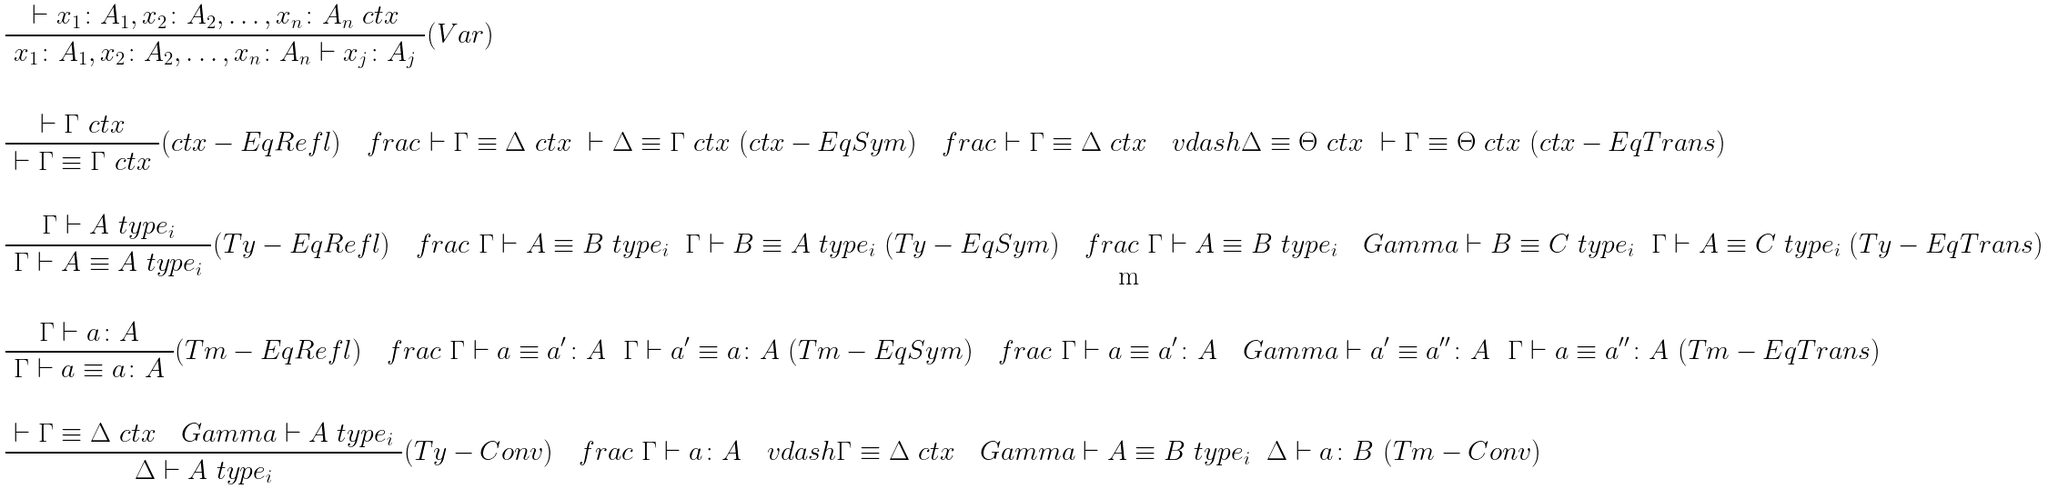Convert formula to latex. <formula><loc_0><loc_0><loc_500><loc_500>& \frac { \ \vdash x _ { 1 } \colon A _ { 1 } , x _ { 2 } \colon A _ { 2 } , \dots , x _ { n } \colon A _ { n } \ c t x \ } { \ x _ { 1 } \colon A _ { 1 } , x _ { 2 } \colon A _ { 2 } , \dots , x _ { n } \colon A _ { n } \vdash x _ { j } \colon A _ { j } \ } ( V a r ) \\ \\ & \frac { \ \vdash \Gamma \ c t x \ } { \ \vdash \Gamma \equiv \Gamma \ c t x \ } ( c t x - E q R e f l ) \quad f r a c { \ \vdash \Gamma \equiv \Delta \ c t x \ } { \ \vdash \Delta \equiv \Gamma \ c t x \ } ( c t x - E q S y m ) \quad f r a c { \ \vdash \Gamma \equiv \Delta \ c t x \quad v d a s h \Delta \equiv \Theta \ c t x \ } { \ \vdash \Gamma \equiv \Theta \ c t x \ } ( c t x - E q T r a n s ) \\ \\ & \frac { \ \Gamma \vdash A \ t y p e _ { i } \ } { \ \Gamma \vdash A \equiv A \ t y p e _ { i } \ } ( T y - E q R e f l ) \quad f r a c { \ \Gamma \vdash A \equiv B \ t y p e _ { i } \ } { \ \Gamma \vdash B \equiv A \ t y p e _ { i } \ } ( T y - E q S y m ) \quad f r a c { \ \Gamma \vdash A \equiv B \ t y p e _ { i } \quad G a m m a \vdash B \equiv C \ t y p e _ { i } \ } { \ \Gamma \vdash A \equiv C \ t y p e _ { i } \ } ( T y - E q T r a n s ) \\ \\ & \frac { \ \Gamma \vdash a \colon A \ } { \ \Gamma \vdash a \equiv a \colon A \ } ( T m - E q R e f l ) \quad f r a c { \ \Gamma \vdash a \equiv a ^ { \prime } \colon A \ } { \ \Gamma \vdash a ^ { \prime } \equiv a \colon A \ } ( T m - E q S y m ) \quad f r a c { \ \Gamma \vdash a \equiv a ^ { \prime } \colon A \quad G a m m a \vdash a ^ { \prime } \equiv a ^ { \prime \prime } \colon A \ } { \ \Gamma \vdash a \equiv a ^ { \prime \prime } \colon A \ } ( T m - E q T r a n s ) \\ \\ & \frac { \ \vdash \Gamma \equiv \Delta \ c t x \quad G a m m a \vdash A \ t y p e _ { i } \ } { \ \Delta \vdash A \ t y p e _ { i } \ } ( T y - C o n v ) \quad f r a c { \ \Gamma \vdash a \colon A \quad v d a s h \Gamma \equiv \Delta \ c t x \quad G a m m a \vdash A \equiv B \ t y p e _ { i } \ } { \ \Delta \vdash a \colon B \ } ( T m - C o n v )</formula> 